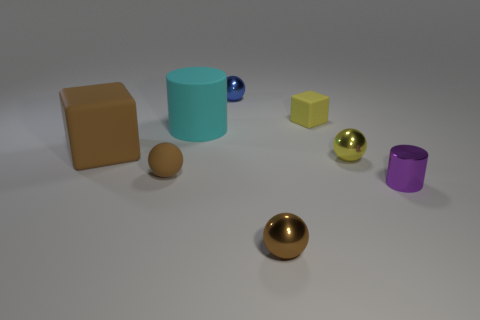What is the shape of the matte object that is in front of the big cylinder and behind the small yellow shiny object?
Keep it short and to the point. Cube. There is a rubber cube right of the tiny metal sphere that is in front of the metal cylinder; what size is it?
Keep it short and to the point. Small. How many purple objects have the same shape as the tiny blue thing?
Offer a terse response. 0. Do the tiny rubber ball and the small cylinder have the same color?
Make the answer very short. No. Is there any other thing that has the same shape as the blue metallic thing?
Keep it short and to the point. Yes. Are there any other balls of the same color as the matte ball?
Your answer should be compact. Yes. Is the material of the cylinder that is on the right side of the small blue metal thing the same as the thing in front of the tiny purple shiny object?
Your answer should be very brief. Yes. What is the color of the small shiny cylinder?
Ensure brevity in your answer.  Purple. There is a cylinder in front of the large object that is right of the brown matte object that is to the left of the brown rubber ball; how big is it?
Your answer should be compact. Small. How many other things are the same size as the yellow matte block?
Keep it short and to the point. 5. 